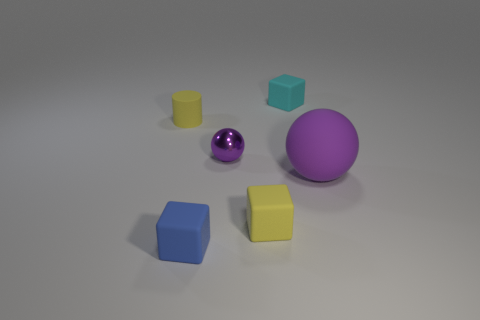Is there any other thing that is made of the same material as the tiny purple thing?
Your answer should be very brief. No. Are there the same number of tiny rubber objects in front of the blue object and big purple matte blocks?
Your answer should be very brief. Yes. Does the matte cube that is behind the purple matte sphere have the same size as the blue thing?
Your answer should be compact. Yes. There is a blue matte object; how many tiny cyan objects are behind it?
Offer a terse response. 1. What is the material of the cube that is to the right of the small blue matte object and in front of the cylinder?
Provide a short and direct response. Rubber. What number of big objects are gray matte balls or cyan rubber blocks?
Keep it short and to the point. 0. The purple metal sphere is what size?
Make the answer very short. Small. There is a tiny metallic thing; what shape is it?
Keep it short and to the point. Sphere. Are there any other things that are the same shape as the big matte object?
Your answer should be very brief. Yes. Are there fewer small yellow matte objects that are left of the yellow matte cylinder than purple balls?
Provide a short and direct response. Yes. 